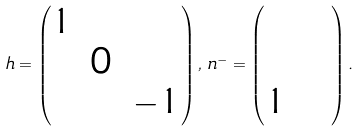<formula> <loc_0><loc_0><loc_500><loc_500>h = \begin{pmatrix} 1 & & \\ & 0 & \, \\ & & \, - 1 \end{pmatrix} , \, n ^ { - } = \begin{pmatrix} & & \\ & & \\ 1 & \, & \, \end{pmatrix} .</formula> 